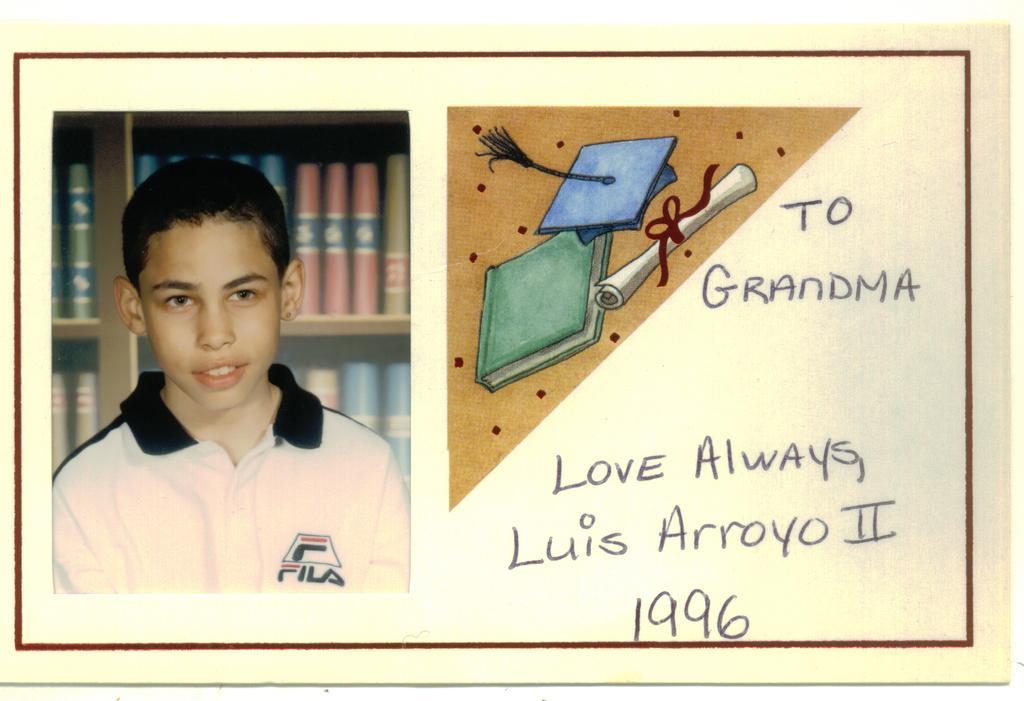In one or two sentences, can you explain what this image depicts? In the image we can see a poster, in the poster we can see a kid. He is smiling. Behind him there are some bookshelves. 